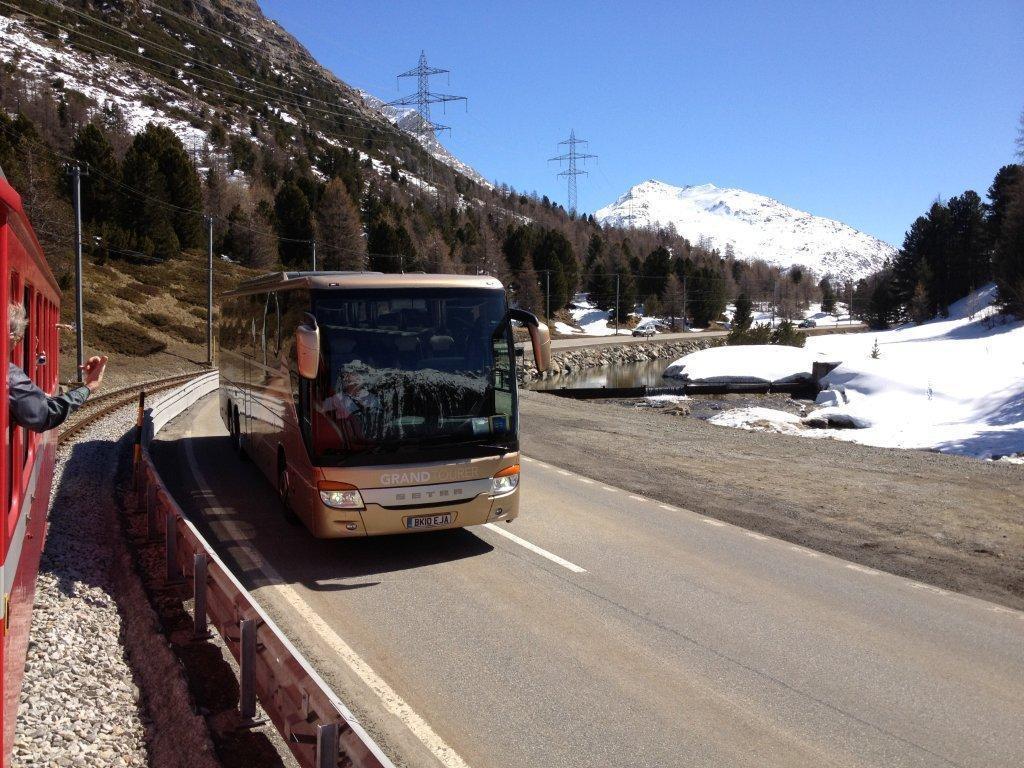Please provide a concise description of this image. There is a road. On the road there is a bus. Near to the road there is a fencing. On the left side there is a railway track. Near to that there are stones. On the railway track there is a train. In the back there are electric poles, trees, hill and water. On the ground there is snow. In the background there is sky. 